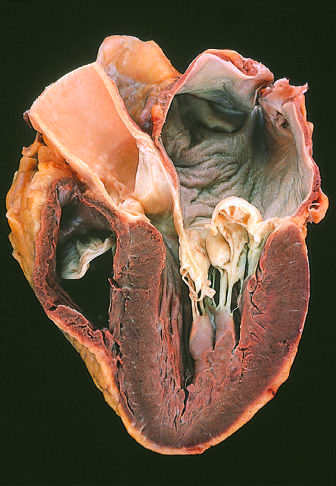s granulomatous host response prominent hooding with prolapse of the posterior mitral leaflet into the left atrium?
Answer the question using a single word or phrase. No 